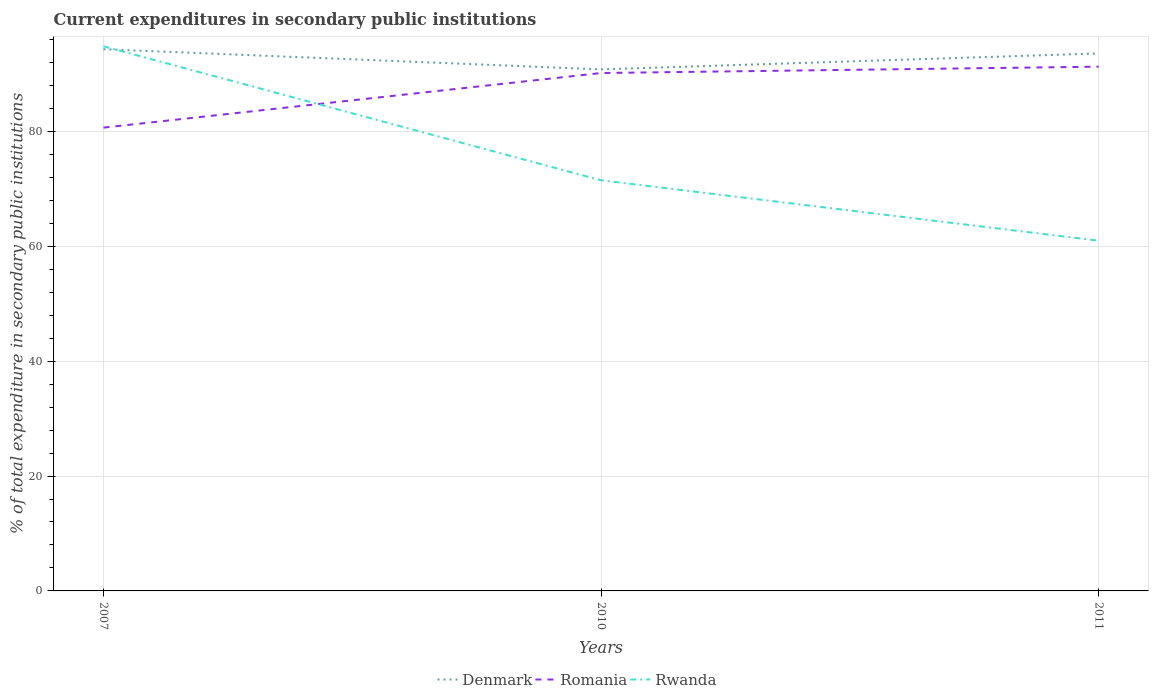How many different coloured lines are there?
Offer a terse response. 3. Does the line corresponding to Denmark intersect with the line corresponding to Rwanda?
Provide a short and direct response. Yes. Is the number of lines equal to the number of legend labels?
Your response must be concise. Yes. Across all years, what is the maximum current expenditures in secondary public institutions in Romania?
Provide a succinct answer. 80.65. What is the total current expenditures in secondary public institutions in Romania in the graph?
Provide a short and direct response. -1.1. What is the difference between the highest and the second highest current expenditures in secondary public institutions in Rwanda?
Keep it short and to the point. 33.84. Is the current expenditures in secondary public institutions in Rwanda strictly greater than the current expenditures in secondary public institutions in Romania over the years?
Offer a very short reply. No. How many lines are there?
Your answer should be very brief. 3. Does the graph contain any zero values?
Your answer should be compact. No. Does the graph contain grids?
Ensure brevity in your answer.  Yes. How many legend labels are there?
Give a very brief answer. 3. How are the legend labels stacked?
Give a very brief answer. Horizontal. What is the title of the graph?
Provide a short and direct response. Current expenditures in secondary public institutions. Does "High income: OECD" appear as one of the legend labels in the graph?
Keep it short and to the point. No. What is the label or title of the Y-axis?
Your answer should be compact. % of total expenditure in secondary public institutions. What is the % of total expenditure in secondary public institutions in Denmark in 2007?
Ensure brevity in your answer.  94.3. What is the % of total expenditure in secondary public institutions of Romania in 2007?
Provide a succinct answer. 80.65. What is the % of total expenditure in secondary public institutions of Rwanda in 2007?
Your response must be concise. 94.8. What is the % of total expenditure in secondary public institutions of Denmark in 2010?
Your response must be concise. 90.79. What is the % of total expenditure in secondary public institutions in Romania in 2010?
Provide a succinct answer. 90.15. What is the % of total expenditure in secondary public institutions in Rwanda in 2010?
Give a very brief answer. 71.48. What is the % of total expenditure in secondary public institutions in Denmark in 2011?
Offer a terse response. 93.56. What is the % of total expenditure in secondary public institutions in Romania in 2011?
Offer a terse response. 91.26. What is the % of total expenditure in secondary public institutions in Rwanda in 2011?
Give a very brief answer. 60.96. Across all years, what is the maximum % of total expenditure in secondary public institutions in Denmark?
Offer a terse response. 94.3. Across all years, what is the maximum % of total expenditure in secondary public institutions of Romania?
Offer a very short reply. 91.26. Across all years, what is the maximum % of total expenditure in secondary public institutions in Rwanda?
Your answer should be compact. 94.8. Across all years, what is the minimum % of total expenditure in secondary public institutions in Denmark?
Ensure brevity in your answer.  90.79. Across all years, what is the minimum % of total expenditure in secondary public institutions of Romania?
Keep it short and to the point. 80.65. Across all years, what is the minimum % of total expenditure in secondary public institutions in Rwanda?
Offer a terse response. 60.96. What is the total % of total expenditure in secondary public institutions in Denmark in the graph?
Offer a very short reply. 278.64. What is the total % of total expenditure in secondary public institutions of Romania in the graph?
Give a very brief answer. 262.05. What is the total % of total expenditure in secondary public institutions in Rwanda in the graph?
Provide a succinct answer. 227.25. What is the difference between the % of total expenditure in secondary public institutions of Denmark in 2007 and that in 2010?
Your answer should be very brief. 3.51. What is the difference between the % of total expenditure in secondary public institutions of Romania in 2007 and that in 2010?
Ensure brevity in your answer.  -9.51. What is the difference between the % of total expenditure in secondary public institutions of Rwanda in 2007 and that in 2010?
Offer a terse response. 23.32. What is the difference between the % of total expenditure in secondary public institutions in Denmark in 2007 and that in 2011?
Provide a short and direct response. 0.73. What is the difference between the % of total expenditure in secondary public institutions in Romania in 2007 and that in 2011?
Ensure brevity in your answer.  -10.61. What is the difference between the % of total expenditure in secondary public institutions in Rwanda in 2007 and that in 2011?
Offer a terse response. 33.84. What is the difference between the % of total expenditure in secondary public institutions in Denmark in 2010 and that in 2011?
Your response must be concise. -2.77. What is the difference between the % of total expenditure in secondary public institutions in Romania in 2010 and that in 2011?
Offer a very short reply. -1.1. What is the difference between the % of total expenditure in secondary public institutions in Rwanda in 2010 and that in 2011?
Ensure brevity in your answer.  10.52. What is the difference between the % of total expenditure in secondary public institutions in Denmark in 2007 and the % of total expenditure in secondary public institutions in Romania in 2010?
Make the answer very short. 4.14. What is the difference between the % of total expenditure in secondary public institutions of Denmark in 2007 and the % of total expenditure in secondary public institutions of Rwanda in 2010?
Provide a succinct answer. 22.82. What is the difference between the % of total expenditure in secondary public institutions of Romania in 2007 and the % of total expenditure in secondary public institutions of Rwanda in 2010?
Provide a succinct answer. 9.17. What is the difference between the % of total expenditure in secondary public institutions of Denmark in 2007 and the % of total expenditure in secondary public institutions of Romania in 2011?
Offer a very short reply. 3.04. What is the difference between the % of total expenditure in secondary public institutions of Denmark in 2007 and the % of total expenditure in secondary public institutions of Rwanda in 2011?
Provide a short and direct response. 33.33. What is the difference between the % of total expenditure in secondary public institutions of Romania in 2007 and the % of total expenditure in secondary public institutions of Rwanda in 2011?
Your response must be concise. 19.68. What is the difference between the % of total expenditure in secondary public institutions in Denmark in 2010 and the % of total expenditure in secondary public institutions in Romania in 2011?
Provide a succinct answer. -0.47. What is the difference between the % of total expenditure in secondary public institutions in Denmark in 2010 and the % of total expenditure in secondary public institutions in Rwanda in 2011?
Give a very brief answer. 29.83. What is the difference between the % of total expenditure in secondary public institutions of Romania in 2010 and the % of total expenditure in secondary public institutions of Rwanda in 2011?
Make the answer very short. 29.19. What is the average % of total expenditure in secondary public institutions of Denmark per year?
Provide a short and direct response. 92.88. What is the average % of total expenditure in secondary public institutions of Romania per year?
Your answer should be very brief. 87.35. What is the average % of total expenditure in secondary public institutions in Rwanda per year?
Ensure brevity in your answer.  75.75. In the year 2007, what is the difference between the % of total expenditure in secondary public institutions in Denmark and % of total expenditure in secondary public institutions in Romania?
Your answer should be very brief. 13.65. In the year 2007, what is the difference between the % of total expenditure in secondary public institutions of Denmark and % of total expenditure in secondary public institutions of Rwanda?
Your answer should be very brief. -0.51. In the year 2007, what is the difference between the % of total expenditure in secondary public institutions of Romania and % of total expenditure in secondary public institutions of Rwanda?
Your answer should be compact. -14.16. In the year 2010, what is the difference between the % of total expenditure in secondary public institutions in Denmark and % of total expenditure in secondary public institutions in Romania?
Provide a succinct answer. 0.63. In the year 2010, what is the difference between the % of total expenditure in secondary public institutions in Denmark and % of total expenditure in secondary public institutions in Rwanda?
Provide a short and direct response. 19.31. In the year 2010, what is the difference between the % of total expenditure in secondary public institutions in Romania and % of total expenditure in secondary public institutions in Rwanda?
Make the answer very short. 18.67. In the year 2011, what is the difference between the % of total expenditure in secondary public institutions in Denmark and % of total expenditure in secondary public institutions in Romania?
Your answer should be compact. 2.31. In the year 2011, what is the difference between the % of total expenditure in secondary public institutions in Denmark and % of total expenditure in secondary public institutions in Rwanda?
Your answer should be very brief. 32.6. In the year 2011, what is the difference between the % of total expenditure in secondary public institutions in Romania and % of total expenditure in secondary public institutions in Rwanda?
Give a very brief answer. 30.29. What is the ratio of the % of total expenditure in secondary public institutions in Denmark in 2007 to that in 2010?
Your answer should be compact. 1.04. What is the ratio of the % of total expenditure in secondary public institutions of Romania in 2007 to that in 2010?
Make the answer very short. 0.89. What is the ratio of the % of total expenditure in secondary public institutions of Rwanda in 2007 to that in 2010?
Your answer should be compact. 1.33. What is the ratio of the % of total expenditure in secondary public institutions of Romania in 2007 to that in 2011?
Give a very brief answer. 0.88. What is the ratio of the % of total expenditure in secondary public institutions of Rwanda in 2007 to that in 2011?
Ensure brevity in your answer.  1.56. What is the ratio of the % of total expenditure in secondary public institutions in Denmark in 2010 to that in 2011?
Provide a succinct answer. 0.97. What is the ratio of the % of total expenditure in secondary public institutions in Romania in 2010 to that in 2011?
Keep it short and to the point. 0.99. What is the ratio of the % of total expenditure in secondary public institutions of Rwanda in 2010 to that in 2011?
Make the answer very short. 1.17. What is the difference between the highest and the second highest % of total expenditure in secondary public institutions of Denmark?
Give a very brief answer. 0.73. What is the difference between the highest and the second highest % of total expenditure in secondary public institutions in Romania?
Your response must be concise. 1.1. What is the difference between the highest and the second highest % of total expenditure in secondary public institutions in Rwanda?
Ensure brevity in your answer.  23.32. What is the difference between the highest and the lowest % of total expenditure in secondary public institutions in Denmark?
Your response must be concise. 3.51. What is the difference between the highest and the lowest % of total expenditure in secondary public institutions of Romania?
Offer a very short reply. 10.61. What is the difference between the highest and the lowest % of total expenditure in secondary public institutions of Rwanda?
Your answer should be compact. 33.84. 